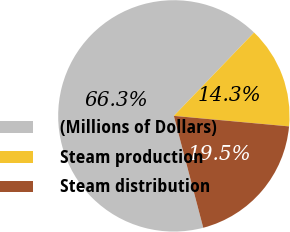Convert chart. <chart><loc_0><loc_0><loc_500><loc_500><pie_chart><fcel>(Millions of Dollars)<fcel>Steam production<fcel>Steam distribution<nl><fcel>66.28%<fcel>14.26%<fcel>19.46%<nl></chart> 